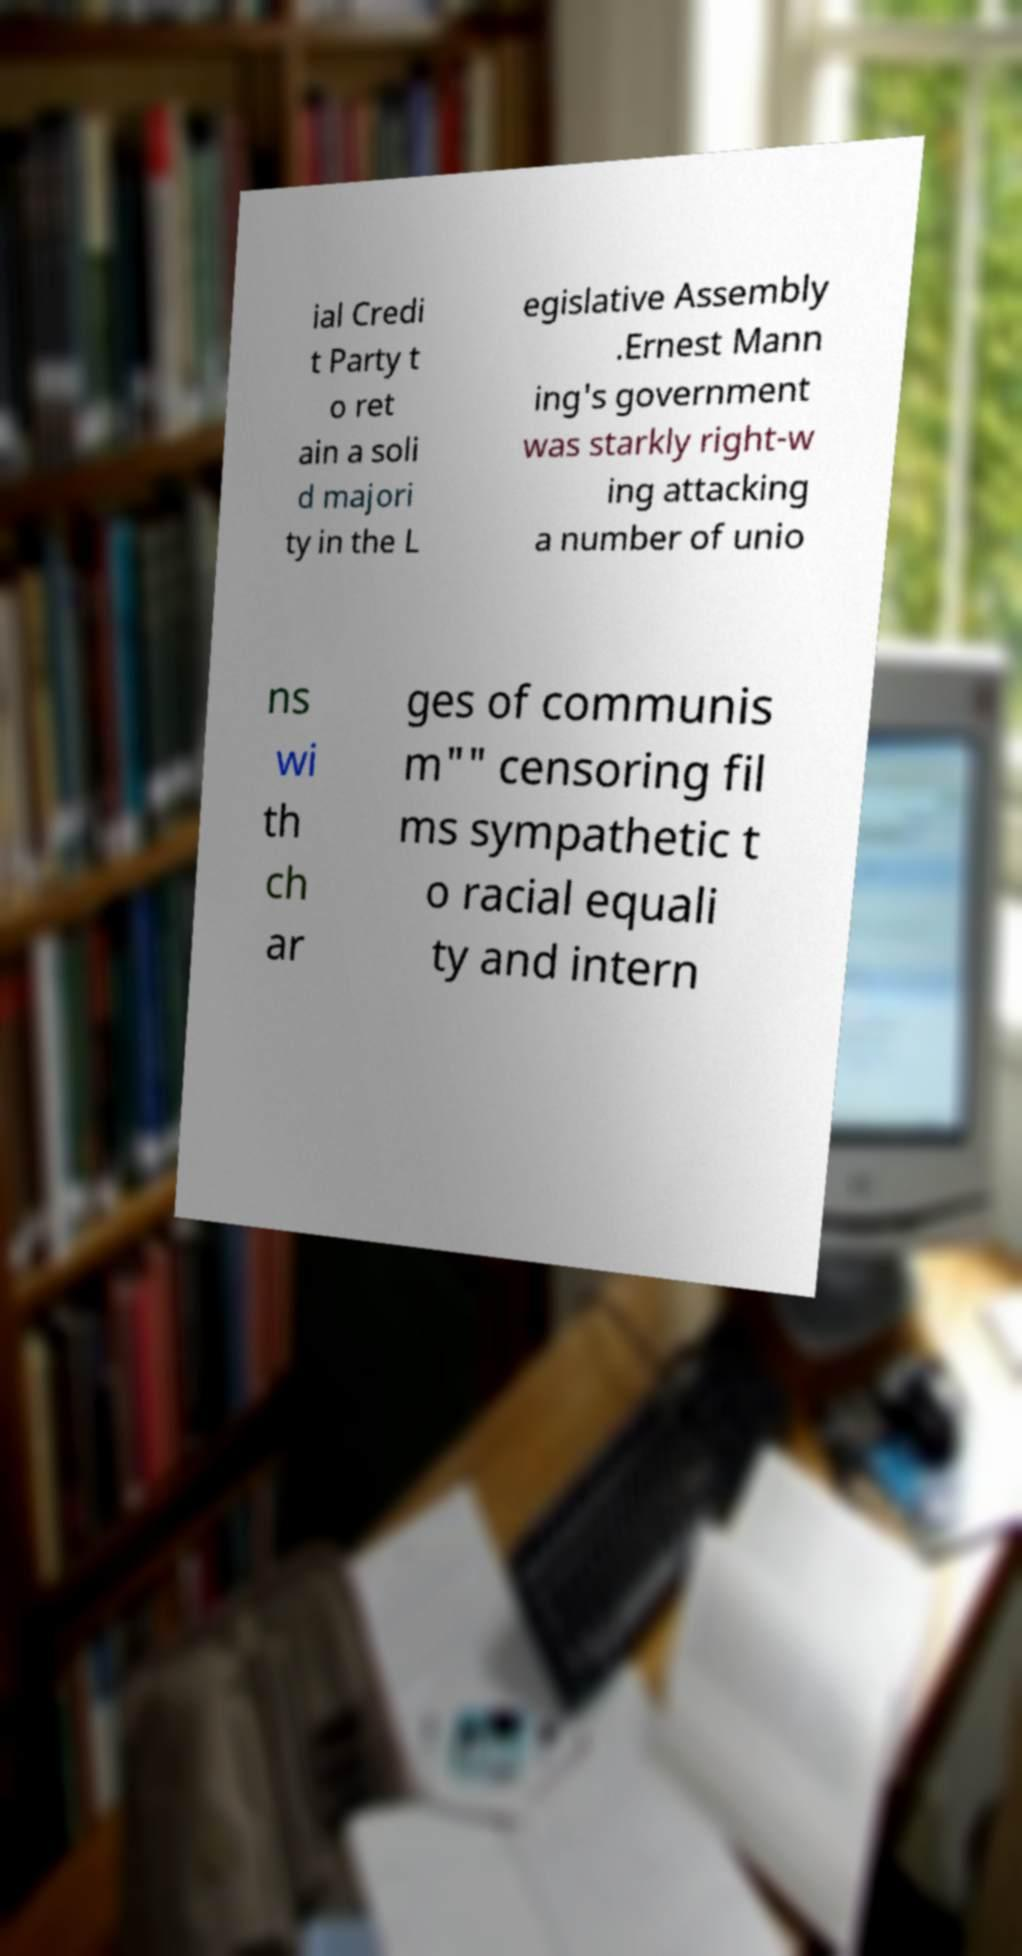There's text embedded in this image that I need extracted. Can you transcribe it verbatim? ial Credi t Party t o ret ain a soli d majori ty in the L egislative Assembly .Ernest Mann ing's government was starkly right-w ing attacking a number of unio ns wi th ch ar ges of communis m"" censoring fil ms sympathetic t o racial equali ty and intern 